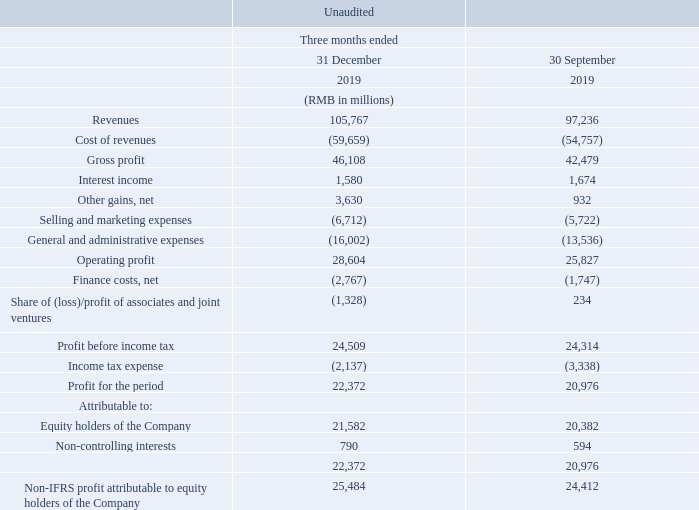Revenues. Revenues increased by 9% to RMB105.8 billion for the fourth quarter of 2019 on a quarter-on-quarter basis.
Revenues from VAS increased by 3% to RMB52,308 million for the fourth quarter of 2019. Online games revenues grew by 6% to RMB30,286 million. The increase was primarily due to revenue contributions from domestic smart phone titles such as Peacekeeper Elite, as well as revenues contributed from Supercell commencing in the fourth quarter of 2019, partly offset by the decrease in revenues from PC client games. Social networks revenues were RMB22,022 million, broadly stable compared to the third quarter of 2019.
Revenues from FinTech and Business Services increased by 12% to RMB29,920 million for the fourth quarter of 2019. The increase mainly reflected the growth of commercial payment, social payment and cloud services.
Revenues from Online Advertising increased by 10% to RMB20,225 million for the fourth quarter of 2019. Social and others advertising revenues grew by 11% to RMB16,274 million. The increase was primarily driven by greater revenues from our mobile advertising network and Weixin Moments, benefitting from the positive seasonality of eCommerce promotional activities in the fourth quarter. Media advertising revenues increased by 8% to RMB3,951 million. The increase mainly reflected greater advertising revenues from our media platforms including Tencent Video, Tencent News and TME.
Cost of revenues. Cost of revenues increased by 9% to RMB59,659 million for the fourth quarter of 2019 on a quarter-onquarter basis. The increase was primarily driven by greater channel costs, costs of FinTech services and content costs. As a percentage of revenues, cost of revenues was 56% for the fourth quarter of 2019, broadly stable compared to the third quarter of 2019.
Cost of revenues for VAS increased by 7% to RMB26,120 million for the fourth quarter of 2019. The increase was primarily due to greater content costs for live broadcast services and major eSport events, as well as higher channel and content costs for smart phone games, including the channel costs attributable to Supercell.
Cost of revenues for FinTech and Business Services increased by 11% to RMB21,520 million for the fourth quarter of 2019. The increase mainly reflected greater costs from increased volume of payment activities and greater scale of cloud services.
Cost of revenues for Online Advertising decreased by 2% to RMB9,241 million for the fourth quarter of 2019. The decrease was primarily driven by lower content costs for our advertising-funded long form video service, partly offset by traffic acquisition costs due to revenue growth from our advertising network.
Selling and marketing expenses. Selling and marketing expenses increased by 17% to RMB6,712 million for the fourth quarter of 2019 on a quarter-on-quarter basis. The increase mainly reflected seasonally greater marketing spending on smart phone games and digital content services, as well as expenses attributable to Supercell.
General and administrative expenses. General and administrative expenses increased by 18% to RMB16,002 million for the fourth quarter of 2019 on a quarter-on-quarter basis. The increase was mainly due to greater R&D expenses and staff costs, including expenses attributable to Supercell.
Share of (loss)/profit of associates and joint ventures. We recorded share of losses of associates and joint ventures of RMB1,328 million for the fourth quarter of 2019, compared to share of profit of RMB234 million for the third quarter of 2019. The movement mainly reflected certain associates booking non-cash fair value changes to their investment portfolios.
Profit attributable to equity holders of the Company. Profit attributable to equity holders of the Company increased by 6% to RMB21,582 million for the fourth quarter of 2019 on a quarter-on-quarter basis. Non-IFRS profit attributable to equity holders of the Company increased by 4% to RMB25,484 million.
What was the primary reason for the increase in VAS revenues? The increase was primarily due to revenue contributions from domestic smart phone titles such as peacekeeper elite, as well as revenues contributed from supercell commencing in the fourth quarter of 2019, partly offset by the decrease in revenues from pc client games. What was the primary reason for the increase in FinTech and Business Services revenue? The increase mainly reflected the growth of commercial payment, social payment and cloud services. What was the primary reason for the increase in Online Advertising revenue? The increase was primarily driven by greater revenues from our mobile advertising network and weixin moments, benefitting from the positive seasonality of ecommerce promotional activities in the fourth quarter. What is the profit margin for the fourth quarter of 2019?
Answer scale should be: percent. 22,372/105,767
Answer: 21.15. What is the profit margin for the third quarter of 2019?
Answer scale should be: percent. 20,976/97,236
Answer: 21.57. What percentage of fourth quarter profits is the profits attributable to equity holders of the company?
Answer scale should be: percent. 21,582/22,372
Answer: 96.47. 